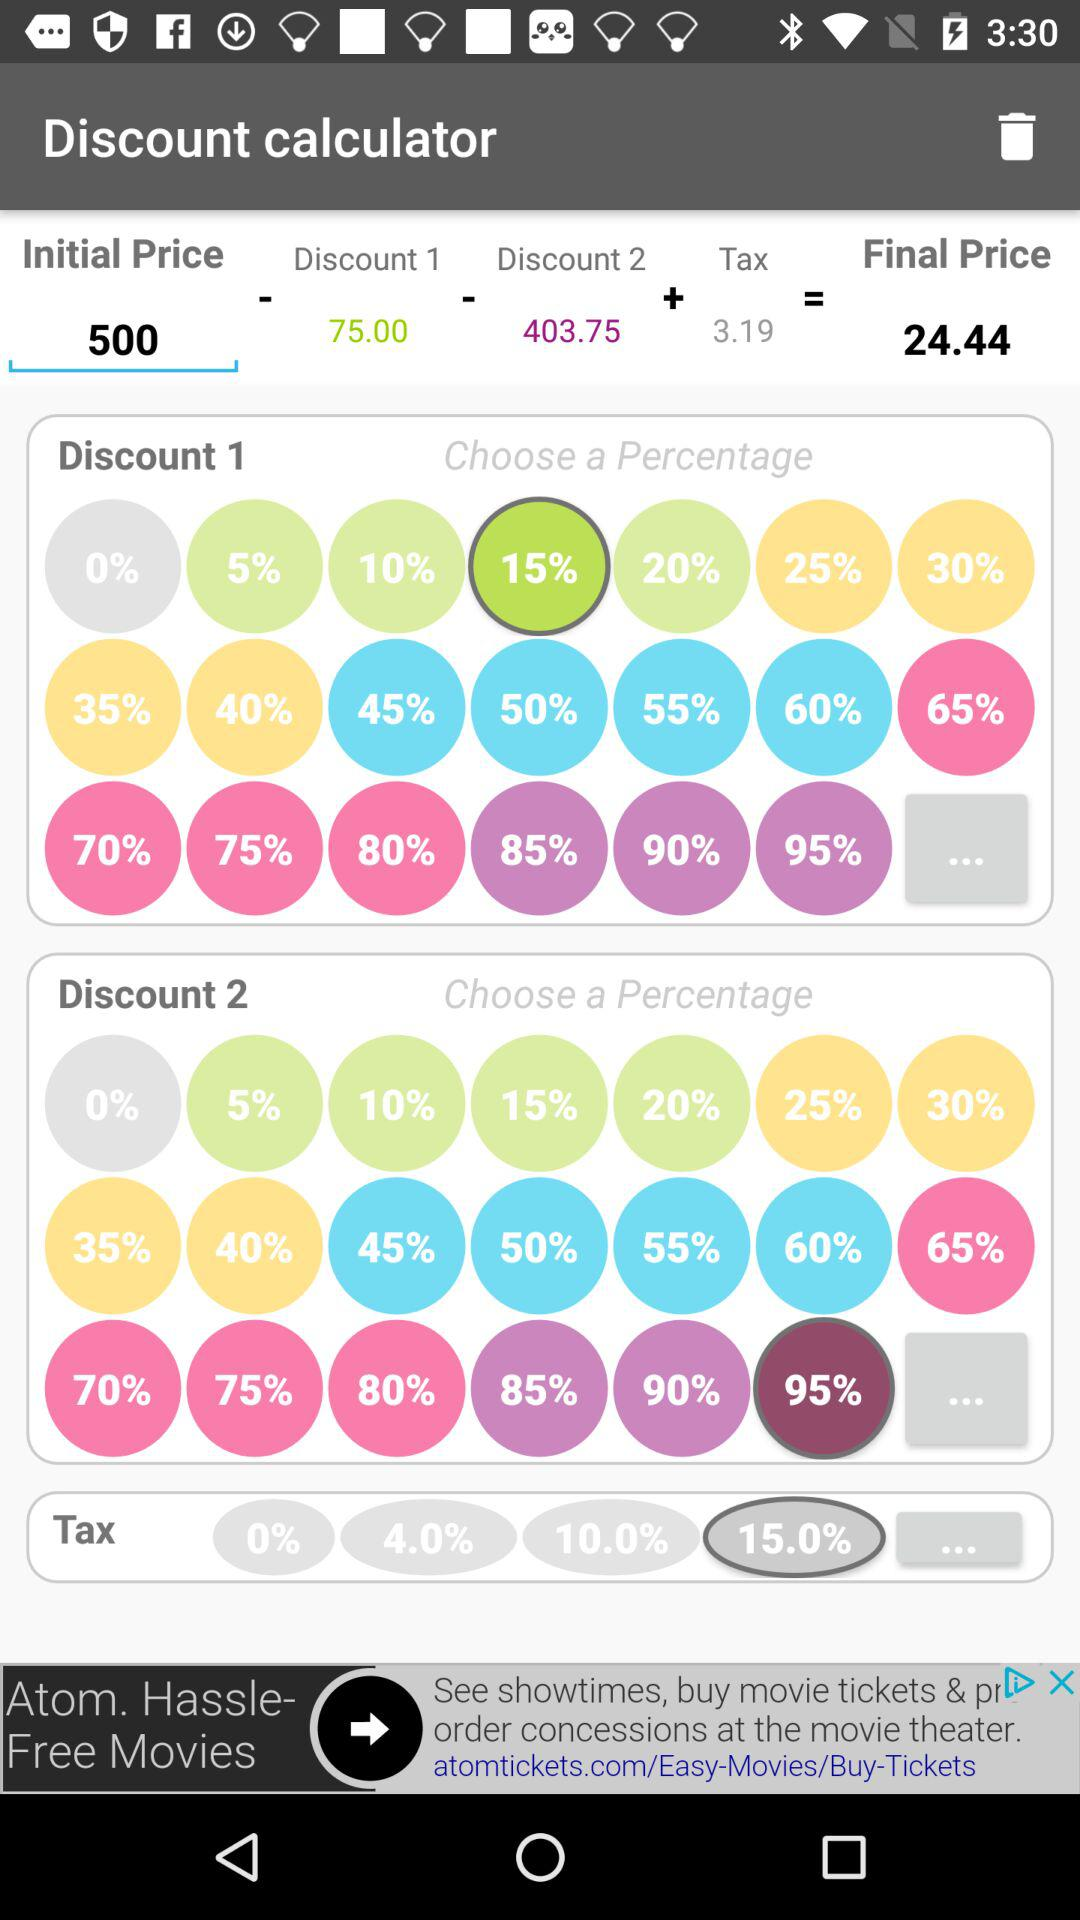What is the selected percentage in "Discount 1"? The selected percentage in "Discount 1" is 15 percent. 